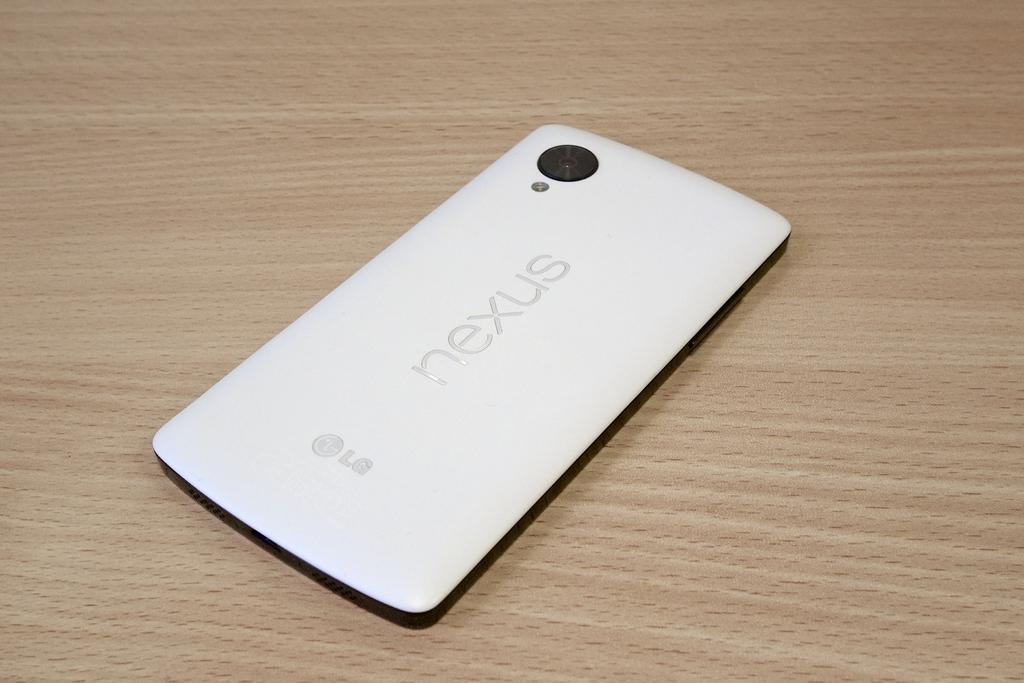<image>
Give a short and clear explanation of the subsequent image. A LG Nexus cellphone on a wooden table. 